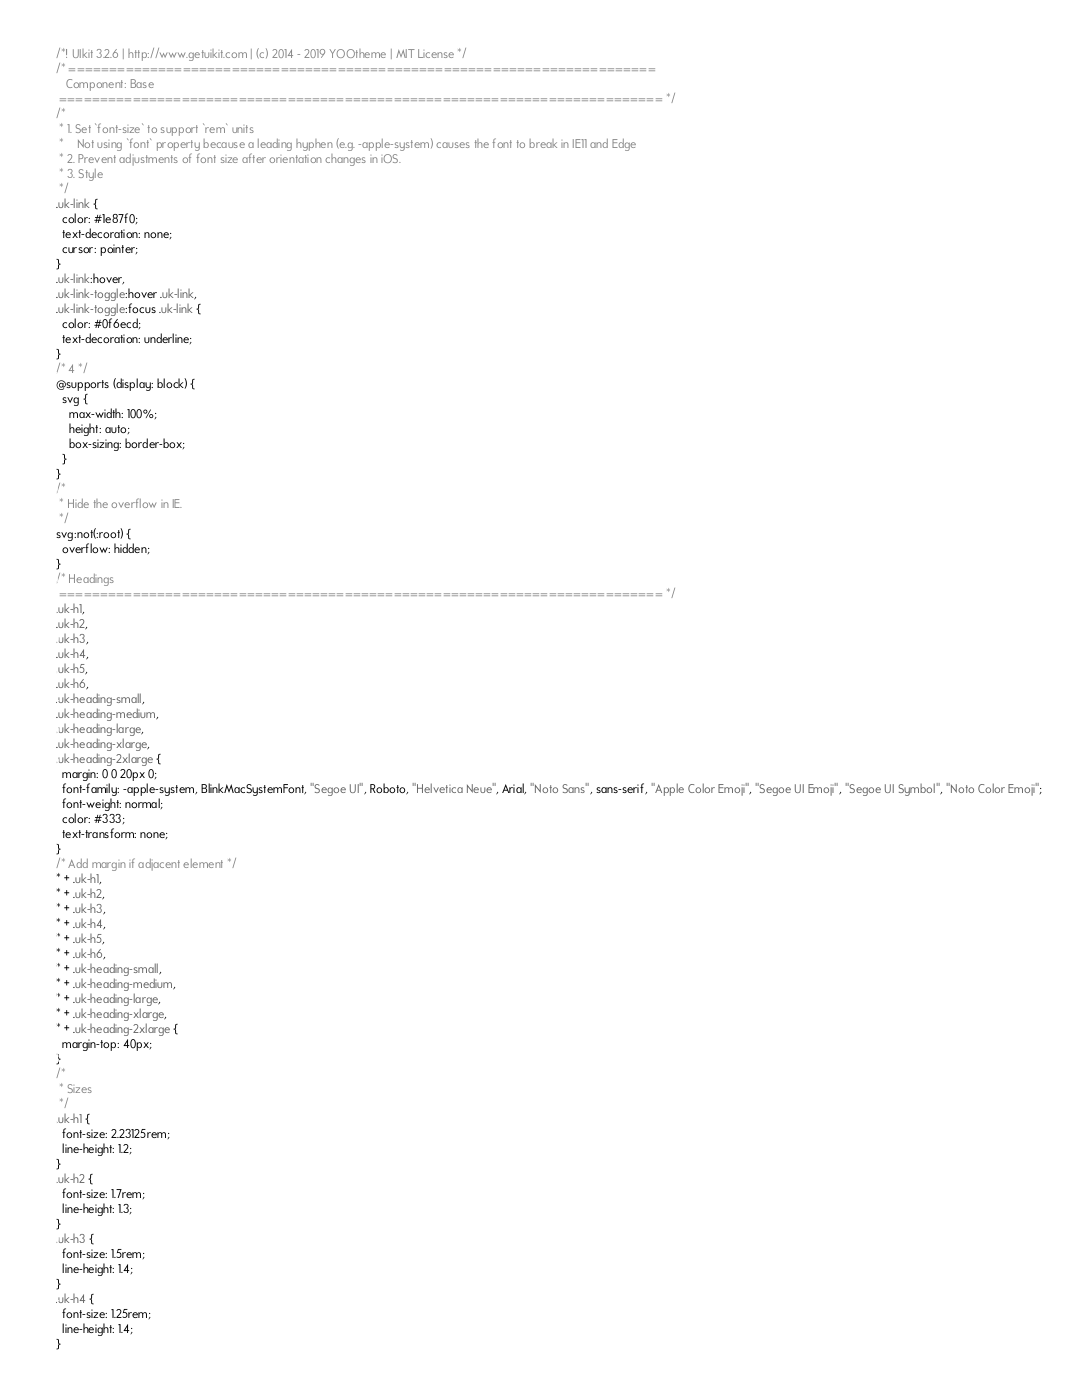<code> <loc_0><loc_0><loc_500><loc_500><_CSS_>/*! UIkit 3.2.6 | http://www.getuikit.com | (c) 2014 - 2019 YOOtheme | MIT License */
/* ========================================================================
   Component: Base
 ========================================================================== */
/*
 * 1. Set `font-size` to support `rem` units
 *    Not using `font` property because a leading hyphen (e.g. -apple-system) causes the font to break in IE11 and Edge
 * 2. Prevent adjustments of font size after orientation changes in iOS.
 * 3. Style
 */
.uk-link {
  color: #1e87f0;
  text-decoration: none;
  cursor: pointer;
}
.uk-link:hover,
.uk-link-toggle:hover .uk-link,
.uk-link-toggle:focus .uk-link {
  color: #0f6ecd;
  text-decoration: underline;
}
/* 4 */
@supports (display: block) {
  svg {
    max-width: 100%;
    height: auto;
    box-sizing: border-box;
  }
}
/*
 * Hide the overflow in IE.
 */
svg:not(:root) {
  overflow: hidden;
}
/* Headings
 ========================================================================== */
.uk-h1,
.uk-h2,
.uk-h3,
.uk-h4,
.uk-h5,
.uk-h6,
.uk-heading-small,
.uk-heading-medium,
.uk-heading-large,
.uk-heading-xlarge,
.uk-heading-2xlarge {
  margin: 0 0 20px 0;
  font-family: -apple-system, BlinkMacSystemFont, "Segoe UI", Roboto, "Helvetica Neue", Arial, "Noto Sans", sans-serif, "Apple Color Emoji", "Segoe UI Emoji", "Segoe UI Symbol", "Noto Color Emoji";
  font-weight: normal;
  color: #333;
  text-transform: none;
}
/* Add margin if adjacent element */
* + .uk-h1,
* + .uk-h2,
* + .uk-h3,
* + .uk-h4,
* + .uk-h5,
* + .uk-h6,
* + .uk-heading-small,
* + .uk-heading-medium,
* + .uk-heading-large,
* + .uk-heading-xlarge,
* + .uk-heading-2xlarge {
  margin-top: 40px;
}
/*
 * Sizes
 */
.uk-h1 {
  font-size: 2.23125rem;
  line-height: 1.2;
}
.uk-h2 {
  font-size: 1.7rem;
  line-height: 1.3;
}
.uk-h3 {
  font-size: 1.5rem;
  line-height: 1.4;
}
.uk-h4 {
  font-size: 1.25rem;
  line-height: 1.4;
}</code> 